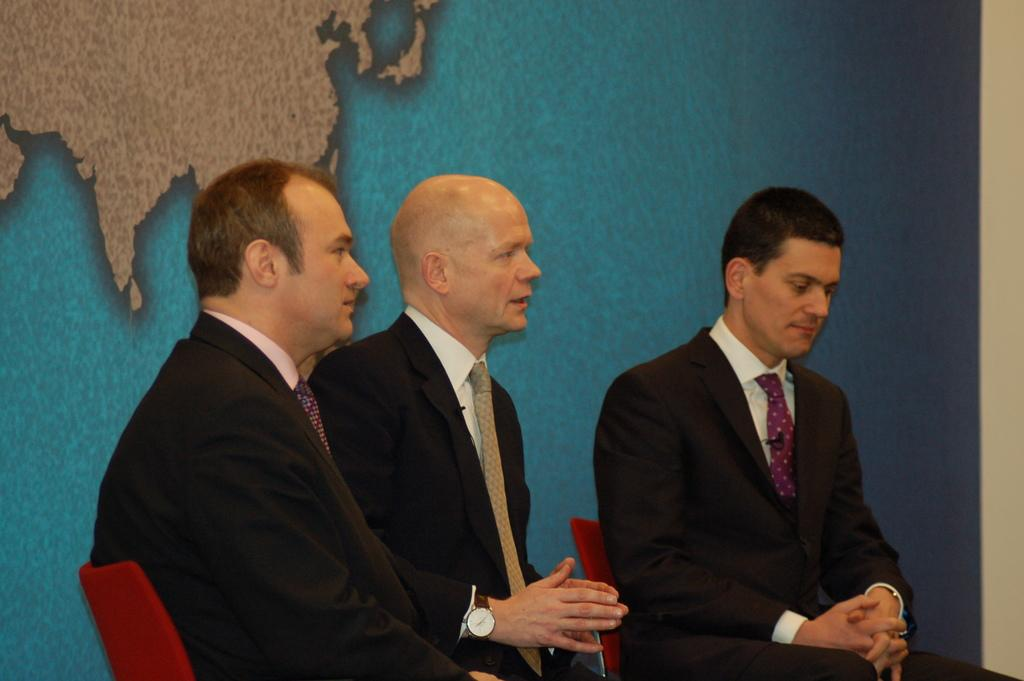How many people are in the image? There are three persons in the image. What are the persons doing in the image? The persons are sitting on chairs. In which direction are the persons looking? The persons are looking to the left side of the image. What type of knot can be seen tied around the scarecrow's throat in the image? There is no scarecrow or knot present in the image; it features three persons sitting on chairs and looking to the left side. 